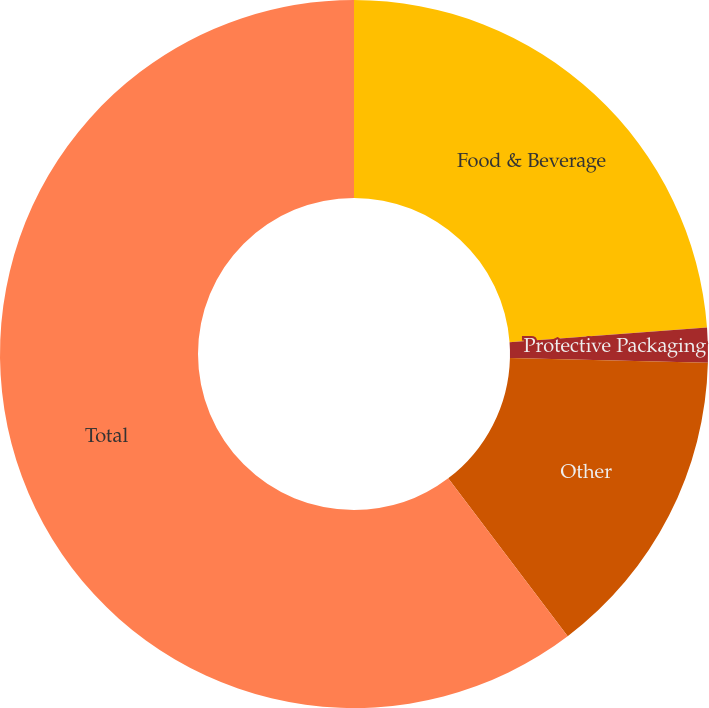<chart> <loc_0><loc_0><loc_500><loc_500><pie_chart><fcel>Food & Beverage<fcel>Protective Packaging<fcel>Other<fcel>Total<nl><fcel>23.81%<fcel>1.59%<fcel>14.29%<fcel>60.32%<nl></chart> 